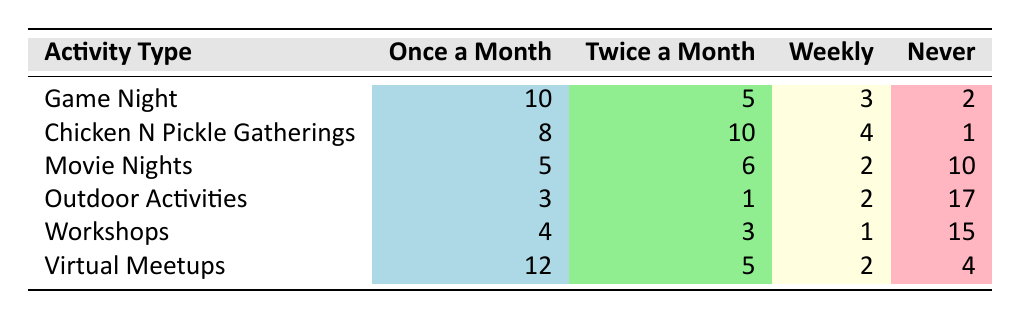What's the frequency of "Game Night" activities that occur once a month? The table shows that the frequency of "Game Night" activities occurring once a month is listed directly. Referring to the corresponding row for "Game Night", the value is 10.
Answer: 10 How many members never participate in "Chicken N Pickle Gatherings"? By looking at the row for "Chicken N Pickle Gatherings", we can see that the frequency for "never" is clearly indicated. That value is 1.
Answer: 1 What is the total number of members who attend "Movie Nights" at least once a month (once a month or twice a month)? To find the total number of members attending "Movie Nights" at least once a month, we add the events for "once a month" and "twice a month". The values are 5 (once a month) + 6 (twice a month) = 11.
Answer: 11 Is it true that more people prefer virtual meetups than outdoor activities weekly? First, we look at the values for "weekly" under both categories. "Virtual Meetups" has a frequency of 2, while "Outdoor Activities" has a frequency of 2 as well. Since both are equal, the statement is false.
Answer: No What is the average frequency of participation for "Workshops"? To calculate the average, we sum the frequencies: 4 (once a month) + 3 (twice a month) + 1 (weekly) + 15 (never) = 23. There are 4 frequency categories, so the average is 23/4 = 5.75.
Answer: 5.75 Which activity type has the highest participation rate for twice a month, and what is that number? Looking at the "twice a month" column, we compare each activity's participation numbers. The highest is from "Chicken N Pickle Gatherings" with a value of 10.
Answer: Chicken N Pickle Gatherings, 10 How many members participate weekly in either "Game Night" or "Virtual Meetups"? For "Game Night," the weekly participation is 3, and for "Virtual Meetups," it is 2. Adding these together gives us 3 + 2 = 5 members participating weekly in either activity.
Answer: 5 Are members more likely to attend workshops or outdoor activities at least once a month? We add the frequencies for "once a month" and "twice a month" for both activities. Workshops: 4 + 3 = 7, Outdoor Activities: 3 + 1 = 4. Since 7 is greater than 4, members are more likely to attend workshops.
Answer: Yes 